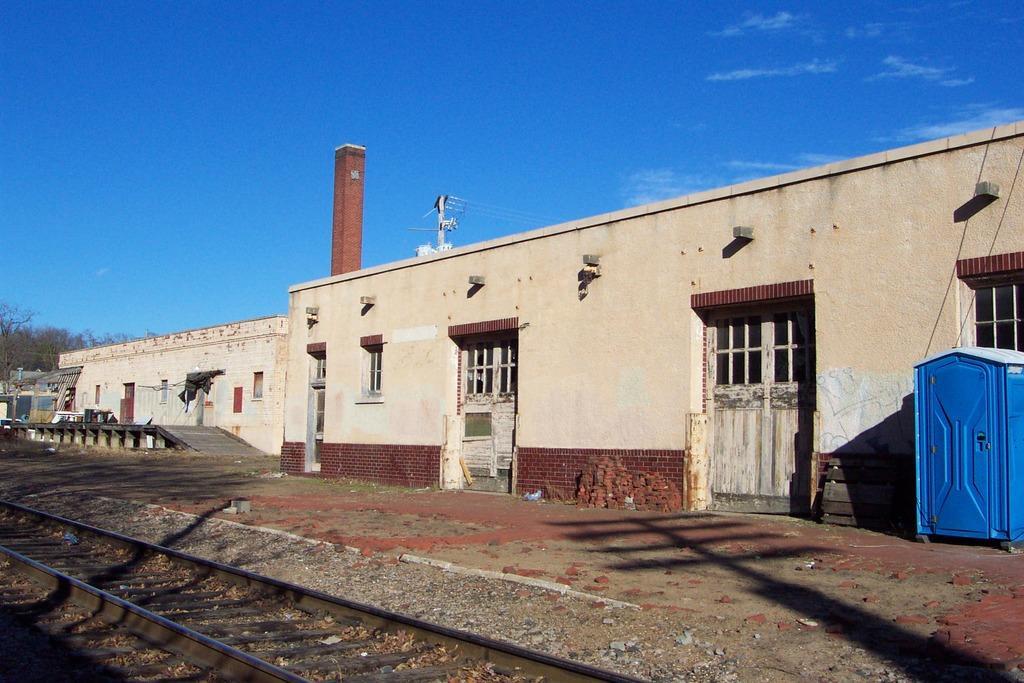In one or two sentences, can you explain what this image depicts? In this image we can see a few buildings, there are some trees, doors, windows, wires, pole and other objects, in front of the building we can see a railway track, in the background we can see the sky with clouds. 